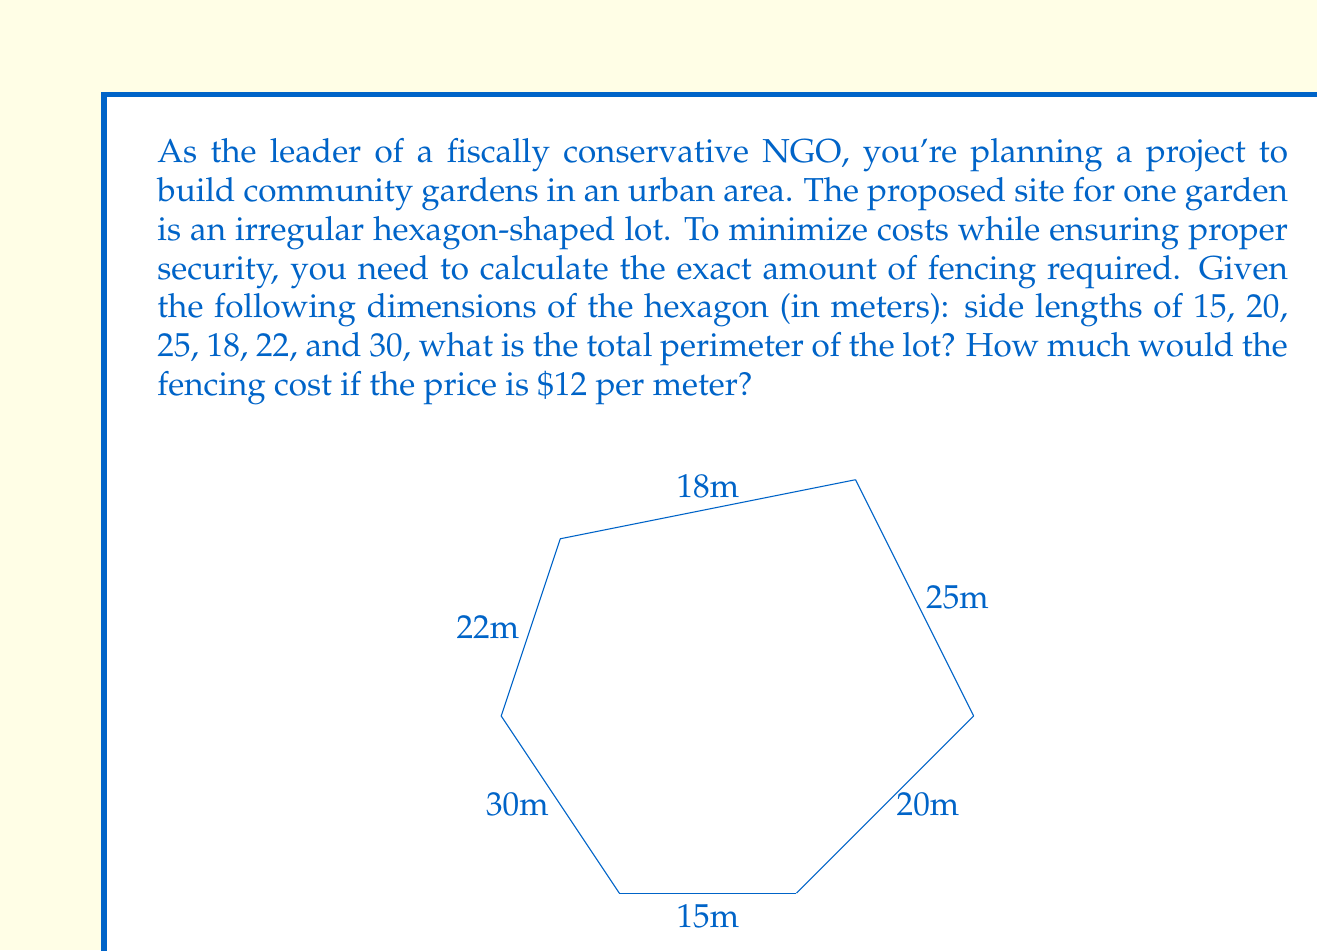Teach me how to tackle this problem. To solve this problem, we'll follow these steps:

1) Calculate the perimeter of the hexagon:
   The perimeter of a polygon is the sum of all its side lengths.
   
   $$\text{Perimeter} = 15 + 20 + 25 + 18 + 22 + 30 = 130 \text{ meters}$$

2) Calculate the cost of fencing:
   Multiply the perimeter by the cost per meter.
   
   $$\text{Cost} = 130 \text{ meters} \times \$12/\text{meter} = \$1,560$$

This approach ensures cost-effective fencing by accurately calculating the exact amount needed, avoiding over-purchasing and wastage. It's a fiscally responsible method that aligns with the NGO's conservative spending principles.

The irregular shape of the lot emphasizes the importance of precise measurements in real-world scenarios, where project sites are often not perfect geometric shapes. This accuracy in calculation directly translates to financial savings, which is crucial for NGOs working with limited budgets.
Answer: The perimeter of the hexagonal lot is 130 meters, and the total cost of fencing would be $1,560. 